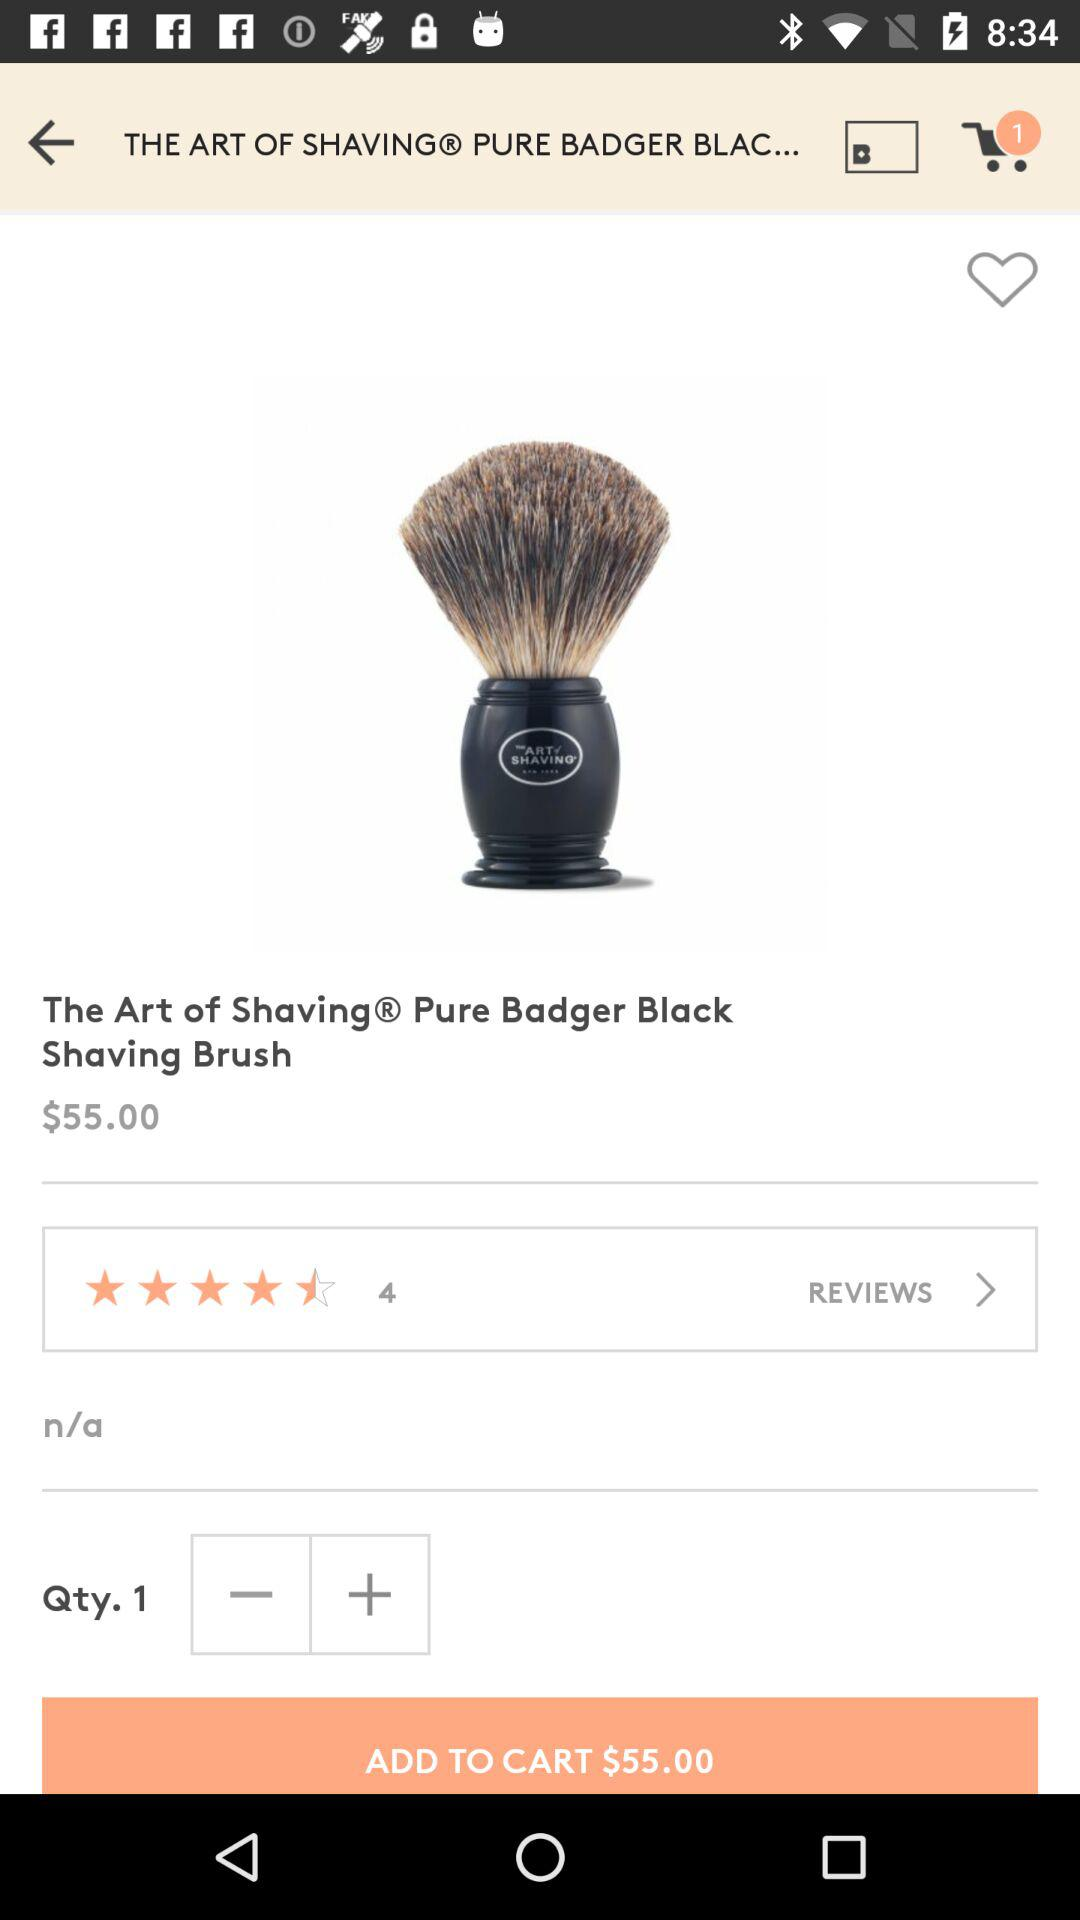How much is the price of the product?
Answer the question using a single word or phrase. $55.00 